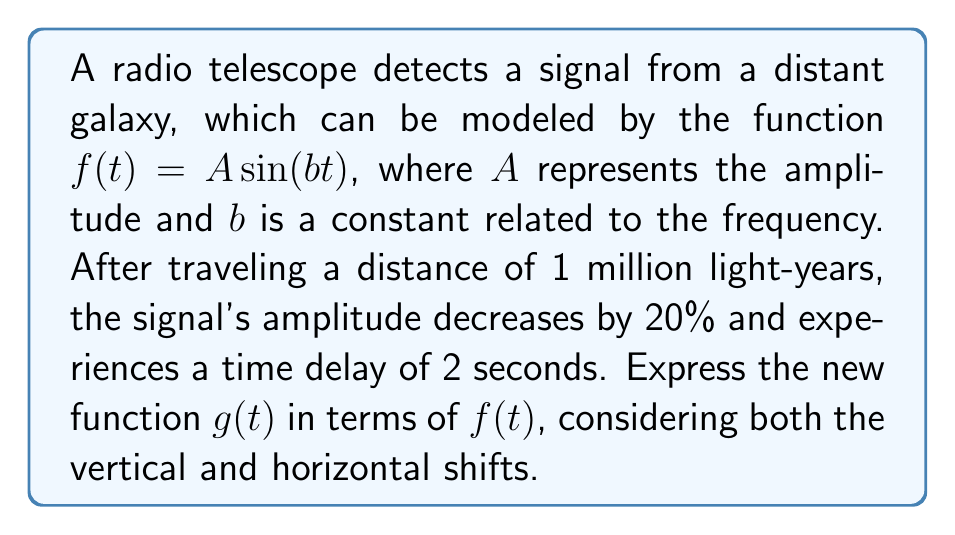Can you answer this question? To solve this problem, we need to consider both the vertical and horizontal transformations of the original function $f(t)$:

1. Vertical transformation (amplitude decrease):
   The amplitude decreases by 20%, so the new amplitude is 80% of the original.
   This can be represented by multiplying $f(t)$ by 0.8:
   $0.8f(t)$

2. Horizontal transformation (time delay):
   The signal experiences a time delay of 2 seconds.
   This can be represented by shifting the function 2 units to the right:
   $f(t-2)$

3. Combining both transformations:
   We apply both the vertical and horizontal transformations simultaneously:
   $g(t) = 0.8f(t-2)$

Therefore, the new function $g(t)$ can be expressed in terms of $f(t)$ as $g(t) = 0.8f(t-2)$.
Answer: $g(t) = 0.8f(t-2)$ 